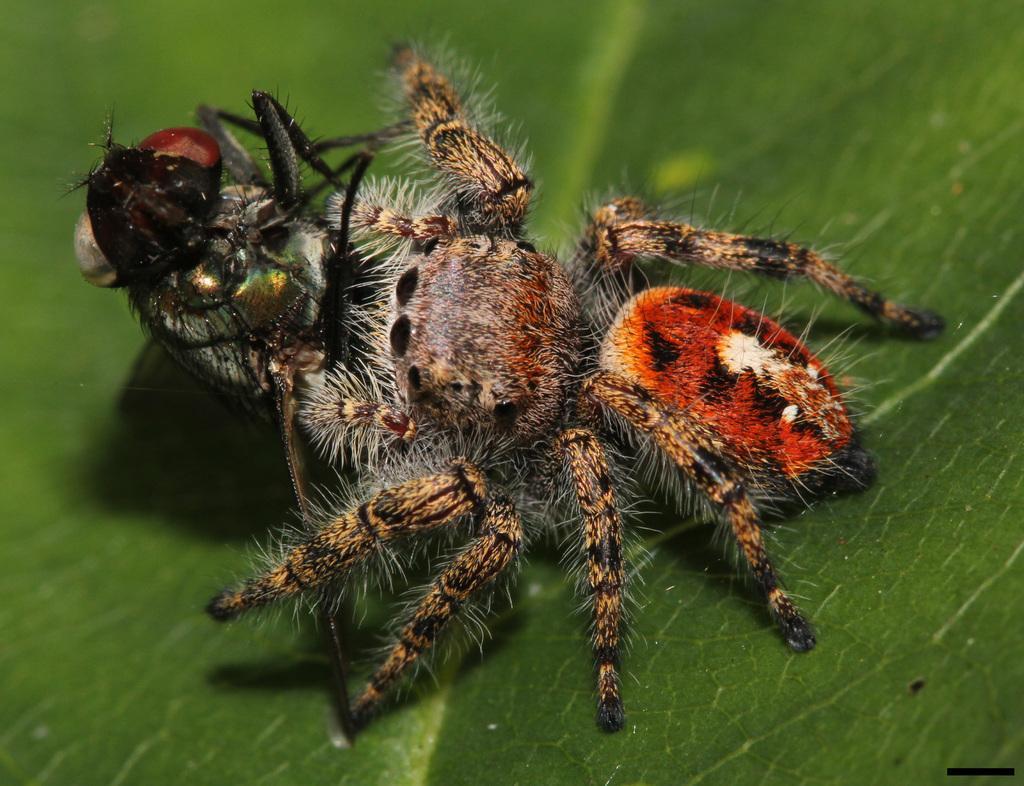Can you describe this image briefly? In this picture we can see an insect on a green surface. 